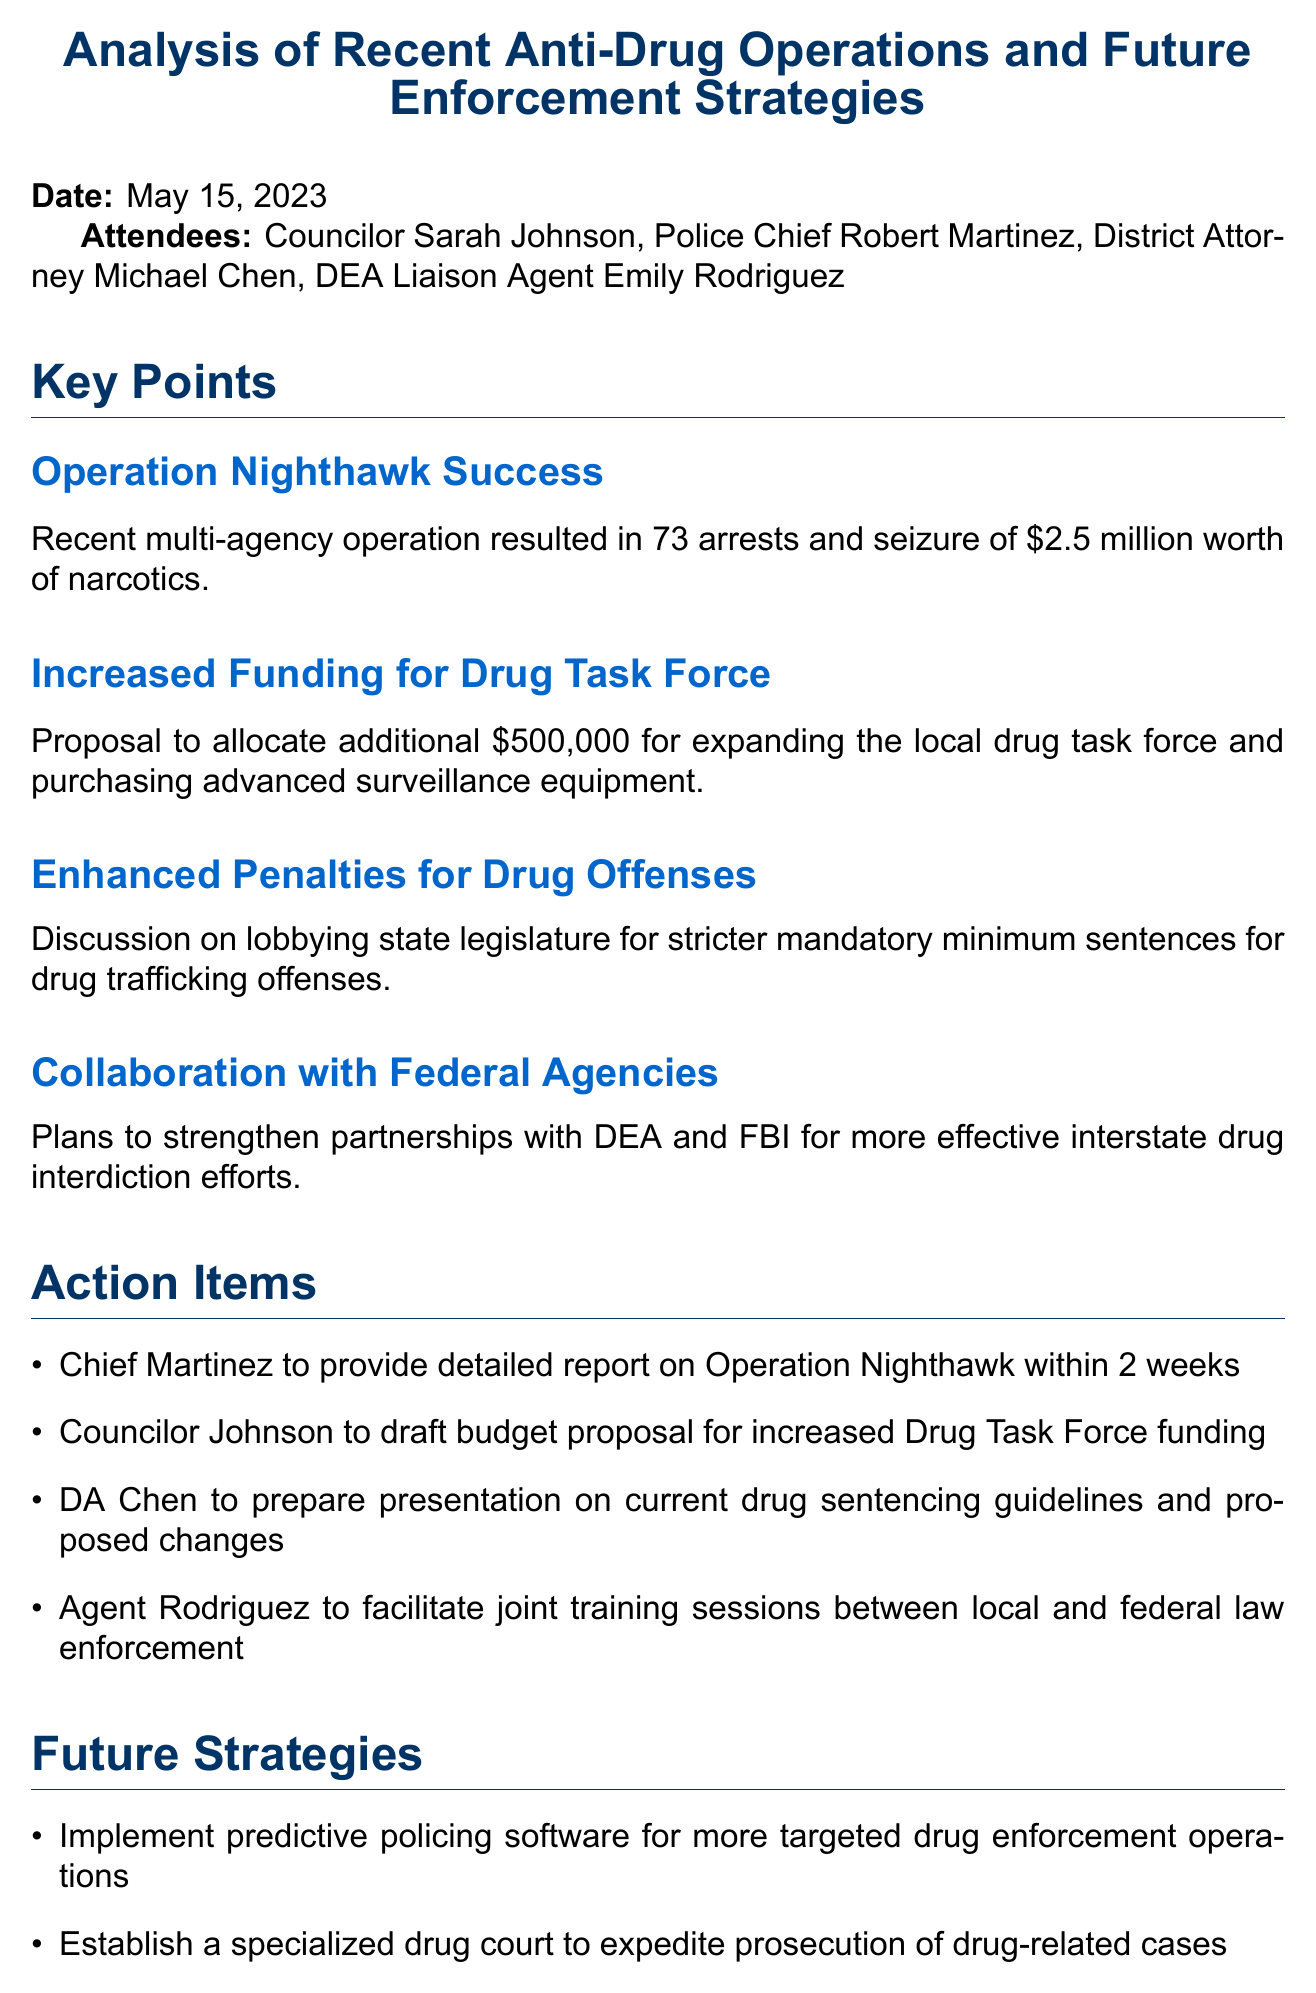What is the date of the meeting? The date of the meeting is explicitly stated at the beginning of the document.
Answer: May 15, 2023 How much were the narcotics worth in Operation Nighthawk? This information is provided in the key points section detailing the success of Operation Nighthawk.
Answer: $2.5 million Who is responsible for providing the detailed report on Operation Nighthawk? The action items section specifies the person responsible for this task.
Answer: Chief Martinez What is the proposed additional funding for the Drug Task Force? The increased funding proposal is outlined in the key points section.
Answer: $500,000 What future strategy involves software? The future strategies section mentions the implementation involving software.
Answer: Predictive policing software How many arrests were made during Operation Nighthawk? The number of arrests is mentioned in the success details of Operation Nighthawk.
Answer: 73 What action item is Councilor Johnson assigned? The action items section lists the specific task assigned to Councilor Johnson.
Answer: Draft budget proposal for increased Drug Task Force funding What agency is mentioned for enhancing collaboration in drug interdiction efforts? This is stated in the key points regarding collaboration with federal agencies.
Answer: DEA and FBI 